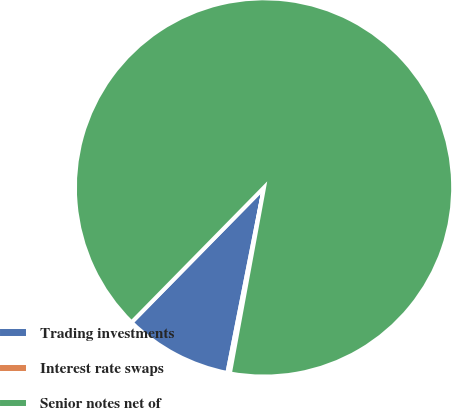Convert chart. <chart><loc_0><loc_0><loc_500><loc_500><pie_chart><fcel>Trading investments<fcel>Interest rate swaps<fcel>Senior notes net of<nl><fcel>9.25%<fcel>0.21%<fcel>90.54%<nl></chart> 